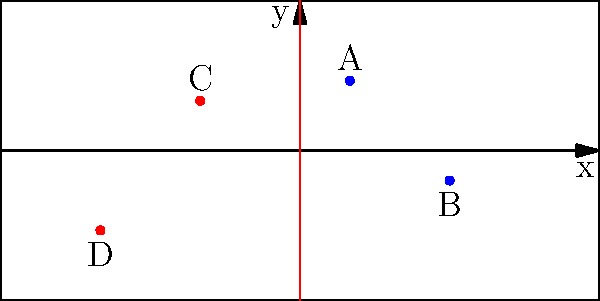In a crucial play during a Blues vs. Predators game, we've plotted the positions of four players on the ice using a coordinate system. Blues players A and B are at coordinates (5, 7) and (15, -3), while Predators players C and D are at (-10, 5) and (-20, -8) respectively. Calculate the total distance traveled if player A passes to player B, who then shoots towards the midpoint between players C and D. Express your answer in terms of coordinate units. Let's break this down step-by-step:

1) First, we need to calculate the distance between A and B:
   Distance AB = $\sqrt{(x_B - x_A)^2 + (y_B - y_A)^2}$
   = $\sqrt{(15 - 5)^2 + (-3 - 7)^2}$
   = $\sqrt{10^2 + (-10)^2}$
   = $\sqrt{200}$
   = $10\sqrt{2}$

2) Next, we need to find the midpoint between C and D:
   Midpoint = $(\frac{x_C + x_D}{2}, \frac{y_C + y_D}{2})$
   = $(\frac{-10 + (-20)}{2}, \frac{5 + (-8)}{2})$
   = $(-15, -1.5)$

3) Now, we calculate the distance from B to this midpoint:
   Distance B to Midpoint = $\sqrt{(x_{mid} - x_B)^2 + (y_{mid} - y_B)^2}$
   = $\sqrt{(-15 - 15)^2 + (-1.5 - (-3))^2}$
   = $\sqrt{(-30)^2 + 1.5^2}$
   = $\sqrt{900 + 2.25}$
   = $\sqrt{902.25}$
   = $30.04$ (rounded to two decimal places)

4) The total distance is the sum of these two distances:
   Total distance = $10\sqrt{2} + 30.04$
   ≈ 44.18 coordinate units
Answer: 44.18 coordinate units 